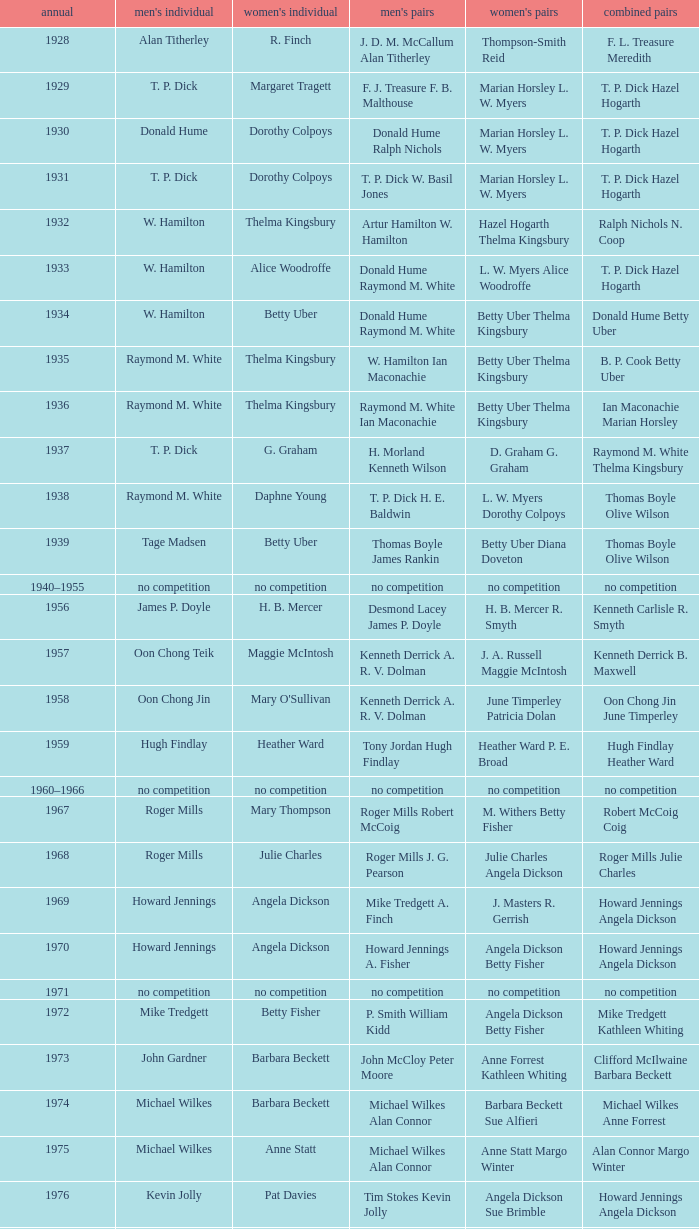Who won the Women's doubles in the year that David Eddy Eddy Sutton won the Men's doubles, and that David Eddy won the Men's singles? Anne Statt Jane Webster. Would you mind parsing the complete table? {'header': ['annual', "men's individual", "women's individual", "men's pairs", "women's pairs", 'combined pairs'], 'rows': [['1928', 'Alan Titherley', 'R. Finch', 'J. D. M. McCallum Alan Titherley', 'Thompson-Smith Reid', 'F. L. Treasure Meredith'], ['1929', 'T. P. Dick', 'Margaret Tragett', 'F. J. Treasure F. B. Malthouse', 'Marian Horsley L. W. Myers', 'T. P. Dick Hazel Hogarth'], ['1930', 'Donald Hume', 'Dorothy Colpoys', 'Donald Hume Ralph Nichols', 'Marian Horsley L. W. Myers', 'T. P. Dick Hazel Hogarth'], ['1931', 'T. P. Dick', 'Dorothy Colpoys', 'T. P. Dick W. Basil Jones', 'Marian Horsley L. W. Myers', 'T. P. Dick Hazel Hogarth'], ['1932', 'W. Hamilton', 'Thelma Kingsbury', 'Artur Hamilton W. Hamilton', 'Hazel Hogarth Thelma Kingsbury', 'Ralph Nichols N. Coop'], ['1933', 'W. Hamilton', 'Alice Woodroffe', 'Donald Hume Raymond M. White', 'L. W. Myers Alice Woodroffe', 'T. P. Dick Hazel Hogarth'], ['1934', 'W. Hamilton', 'Betty Uber', 'Donald Hume Raymond M. White', 'Betty Uber Thelma Kingsbury', 'Donald Hume Betty Uber'], ['1935', 'Raymond M. White', 'Thelma Kingsbury', 'W. Hamilton Ian Maconachie', 'Betty Uber Thelma Kingsbury', 'B. P. Cook Betty Uber'], ['1936', 'Raymond M. White', 'Thelma Kingsbury', 'Raymond M. White Ian Maconachie', 'Betty Uber Thelma Kingsbury', 'Ian Maconachie Marian Horsley'], ['1937', 'T. P. Dick', 'G. Graham', 'H. Morland Kenneth Wilson', 'D. Graham G. Graham', 'Raymond M. White Thelma Kingsbury'], ['1938', 'Raymond M. White', 'Daphne Young', 'T. P. Dick H. E. Baldwin', 'L. W. Myers Dorothy Colpoys', 'Thomas Boyle Olive Wilson'], ['1939', 'Tage Madsen', 'Betty Uber', 'Thomas Boyle James Rankin', 'Betty Uber Diana Doveton', 'Thomas Boyle Olive Wilson'], ['1940–1955', 'no competition', 'no competition', 'no competition', 'no competition', 'no competition'], ['1956', 'James P. Doyle', 'H. B. Mercer', 'Desmond Lacey James P. Doyle', 'H. B. Mercer R. Smyth', 'Kenneth Carlisle R. Smyth'], ['1957', 'Oon Chong Teik', 'Maggie McIntosh', 'Kenneth Derrick A. R. V. Dolman', 'J. A. Russell Maggie McIntosh', 'Kenneth Derrick B. Maxwell'], ['1958', 'Oon Chong Jin', "Mary O'Sullivan", 'Kenneth Derrick A. R. V. Dolman', 'June Timperley Patricia Dolan', 'Oon Chong Jin June Timperley'], ['1959', 'Hugh Findlay', 'Heather Ward', 'Tony Jordan Hugh Findlay', 'Heather Ward P. E. Broad', 'Hugh Findlay Heather Ward'], ['1960–1966', 'no competition', 'no competition', 'no competition', 'no competition', 'no competition'], ['1967', 'Roger Mills', 'Mary Thompson', 'Roger Mills Robert McCoig', 'M. Withers Betty Fisher', 'Robert McCoig Coig'], ['1968', 'Roger Mills', 'Julie Charles', 'Roger Mills J. G. Pearson', 'Julie Charles Angela Dickson', 'Roger Mills Julie Charles'], ['1969', 'Howard Jennings', 'Angela Dickson', 'Mike Tredgett A. Finch', 'J. Masters R. Gerrish', 'Howard Jennings Angela Dickson'], ['1970', 'Howard Jennings', 'Angela Dickson', 'Howard Jennings A. Fisher', 'Angela Dickson Betty Fisher', 'Howard Jennings Angela Dickson'], ['1971', 'no competition', 'no competition', 'no competition', 'no competition', 'no competition'], ['1972', 'Mike Tredgett', 'Betty Fisher', 'P. Smith William Kidd', 'Angela Dickson Betty Fisher', 'Mike Tredgett Kathleen Whiting'], ['1973', 'John Gardner', 'Barbara Beckett', 'John McCloy Peter Moore', 'Anne Forrest Kathleen Whiting', 'Clifford McIlwaine Barbara Beckett'], ['1974', 'Michael Wilkes', 'Barbara Beckett', 'Michael Wilkes Alan Connor', 'Barbara Beckett Sue Alfieri', 'Michael Wilkes Anne Forrest'], ['1975', 'Michael Wilkes', 'Anne Statt', 'Michael Wilkes Alan Connor', 'Anne Statt Margo Winter', 'Alan Connor Margo Winter'], ['1976', 'Kevin Jolly', 'Pat Davies', 'Tim Stokes Kevin Jolly', 'Angela Dickson Sue Brimble', 'Howard Jennings Angela Dickson'], ['1977', 'David Eddy', 'Paula Kilvington', 'David Eddy Eddy Sutton', 'Anne Statt Jane Webster', 'David Eddy Barbara Giles'], ['1978', 'Mike Tredgett', 'Gillian Gilks', 'David Eddy Eddy Sutton', 'Barbara Sutton Marjan Ridder', 'Elliot Stuart Gillian Gilks'], ['1979', 'Kevin Jolly', 'Nora Perry', 'Ray Stevens Mike Tredgett', 'Barbara Sutton Nora Perry', 'Mike Tredgett Nora Perry'], ['1980', 'Thomas Kihlström', 'Jane Webster', 'Thomas Kihlström Bengt Fröman', 'Jane Webster Karen Puttick', 'Billy Gilliland Karen Puttick'], ['1981', 'Ray Stevens', 'Gillian Gilks', 'Ray Stevens Mike Tredgett', 'Gillian Gilks Paula Kilvington', 'Mike Tredgett Nora Perry'], ['1982', 'Steve Baddeley', 'Karen Bridge', 'David Eddy Eddy Sutton', 'Karen Chapman Sally Podger', 'Billy Gilliland Karen Chapman'], ['1983', 'Steve Butler', 'Sally Podger', 'Mike Tredgett Dipak Tailor', 'Nora Perry Jane Webster', 'Dipak Tailor Nora Perry'], ['1984', 'Steve Butler', 'Karen Beckman', 'Mike Tredgett Martin Dew', 'Helen Troke Karen Chapman', 'Mike Tredgett Karen Chapman'], ['1985', 'Morten Frost', 'Charlotte Hattens', 'Billy Gilliland Dan Travers', 'Gillian Gilks Helen Troke', 'Martin Dew Gillian Gilks'], ['1986', 'Darren Hall', 'Fiona Elliott', 'Martin Dew Dipak Tailor', 'Karen Beckman Sara Halsall', 'Jesper Knudsen Nettie Nielsen'], ['1987', 'Darren Hall', 'Fiona Elliott', 'Martin Dew Darren Hall', 'Karen Beckman Sara Halsall', 'Martin Dew Gillian Gilks'], ['1988', 'Vimal Kumar', 'Lee Jung-mi', 'Richard Outterside Mike Brown', 'Fiona Elliott Sara Halsall', 'Martin Dew Gillian Gilks'], ['1989', 'Darren Hall', 'Bang Soo-hyun', 'Nick Ponting Dave Wright', 'Karen Beckman Sara Sankey', 'Mike Brown Jillian Wallwork'], ['1990', 'Mathew Smith', 'Joanne Muggeridge', 'Nick Ponting Dave Wright', 'Karen Chapman Sara Sankey', 'Dave Wright Claire Palmer'], ['1991', 'Vimal Kumar', 'Denyse Julien', 'Nick Ponting Dave Wright', 'Cheryl Johnson Julie Bradbury', 'Nick Ponting Joanne Wright'], ['1992', 'Wei Yan', 'Fiona Smith', 'Michael Adams Chris Rees', 'Denyse Julien Doris Piché', 'Andy Goode Joanne Wright'], ['1993', 'Anders Nielsen', 'Sue Louis Lane', 'Nick Ponting Dave Wright', 'Julie Bradbury Sara Sankey', 'Nick Ponting Joanne Wright'], ['1994', 'Darren Hall', 'Marina Andrievskaya', 'Michael Adams Simon Archer', 'Julie Bradbury Joanne Wright', 'Chris Hunt Joanne Wright'], ['1995', 'Peter Rasmussen', 'Denyse Julien', 'Andrei Andropov Nikolai Zuyev', 'Julie Bradbury Joanne Wright', 'Nick Ponting Joanne Wright'], ['1996', 'Colin Haughton', 'Elena Rybkina', 'Andrei Andropov Nikolai Zuyev', 'Elena Rybkina Marina Yakusheva', 'Nikolai Zuyev Marina Yakusheva'], ['1997', 'Chris Bruil', 'Kelly Morgan', 'Ian Pearson James Anderson', 'Nicole van Hooren Brenda Conijn', 'Quinten van Dalm Nicole van Hooren'], ['1998', 'Dicky Palyama', 'Brenda Beenhakker', 'James Anderson Ian Sullivan', 'Sara Sankey Ella Tripp', 'James Anderson Sara Sankey'], ['1999', 'Daniel Eriksson', 'Marina Andrievskaya', 'Joachim Tesche Jean-Philippe Goyette', 'Marina Andrievskaya Catrine Bengtsson', 'Henrik Andersson Marina Andrievskaya'], ['2000', 'Richard Vaughan', 'Marina Yakusheva', 'Joachim Andersson Peter Axelsson', 'Irina Ruslyakova Marina Yakusheva', 'Peter Jeffrey Joanne Davies'], ['2001', 'Irwansyah', 'Brenda Beenhakker', 'Vincent Laigle Svetoslav Stoyanov', 'Sara Sankey Ella Tripp', 'Nikolai Zuyev Marina Yakusheva'], ['2002', 'Irwansyah', 'Karina de Wit', 'Nikolai Zuyev Stanislav Pukhov', 'Ella Tripp Joanne Wright', 'Nikolai Zuyev Marina Yakusheva'], ['2003', 'Irwansyah', 'Ella Karachkova', 'Ashley Thilthorpe Kristian Roebuck', 'Ella Karachkova Anastasia Russkikh', 'Alexandr Russkikh Anastasia Russkikh'], ['2004', 'Nathan Rice', 'Petya Nedelcheva', 'Reuben Gordown Aji Basuki Sindoro', 'Petya Nedelcheva Yuan Wemyss', 'Matthew Hughes Kelly Morgan'], ['2005', 'Chetan Anand', 'Eleanor Cox', 'Andrew Ellis Dean George', 'Hayley Connor Heather Olver', 'Valiyaveetil Diju Jwala Gutta'], ['2006', 'Irwansyah', 'Huang Chia-chi', 'Matthew Hughes Martyn Lewis', 'Natalie Munt Mariana Agathangelou', 'Kristian Roebuck Natalie Munt'], ['2007', 'Marc Zwiebler', 'Jill Pittard', 'Wojciech Szkudlarczyk Adam Cwalina', 'Chloe Magee Bing Huang', 'Wojciech Szkudlarczyk Malgorzata Kurdelska'], ['2008', 'Brice Leverdez', 'Kati Tolmoff', 'Andrew Bowman Martyn Lewis', 'Mariana Agathangelou Jillie Cooper', 'Watson Briggs Jillie Cooper'], ['2009', 'Kristian Nielsen', 'Tatjana Bibik', 'Vitaliy Durkin Alexandr Nikolaenko', 'Valeria Sorokina Nina Vislova', 'Vitaliy Durkin Nina Vislova'], ['2010', 'Pablo Abián', 'Anita Raj Kaur', 'Peter Käsbauer Josche Zurwonne', 'Joanne Quay Swee Ling Anita Raj Kaur', 'Peter Käsbauer Johanna Goliszewski'], ['2011', 'Niluka Karunaratne', 'Nicole Schaller', 'Chris Coles Matthew Nottingham', 'Ng Hui Ern Ng Hui Lin', 'Martin Campbell Ng Hui Lin'], ['2012', 'Chou Tien-chen', 'Chiang Mei-hui', 'Marcus Ellis Paul Van Rietvelde', 'Gabrielle White Lauren Smith', 'Marcus Ellis Gabrielle White']]} 